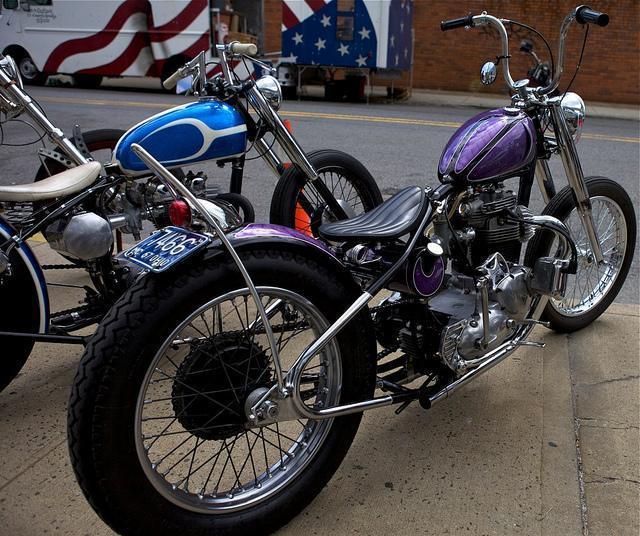How many bikes are in the picture?
Give a very brief answer. 2. How many motorcycles are there?
Give a very brief answer. 2. How many wheels is on this vehicle?
Give a very brief answer. 2. How many motorcycles?
Give a very brief answer. 2. How many motorcycles are in the photo?
Give a very brief answer. 2. 